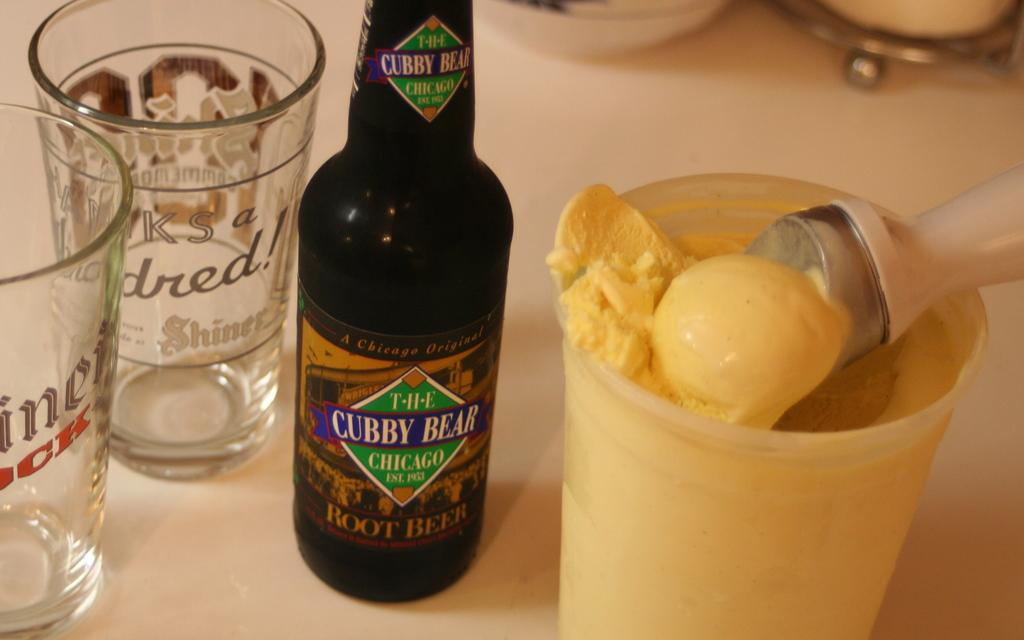<image>
Summarize the visual content of the image. The Cubby Bear Chicago Beer drink that is established in 1953. 